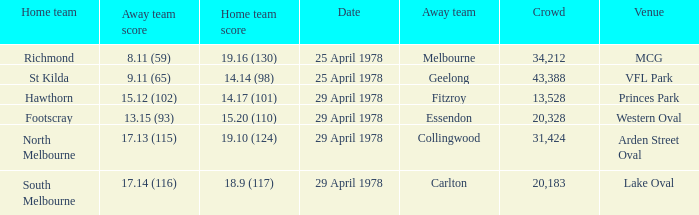What was the away team that played at Princes Park? Fitzroy. 